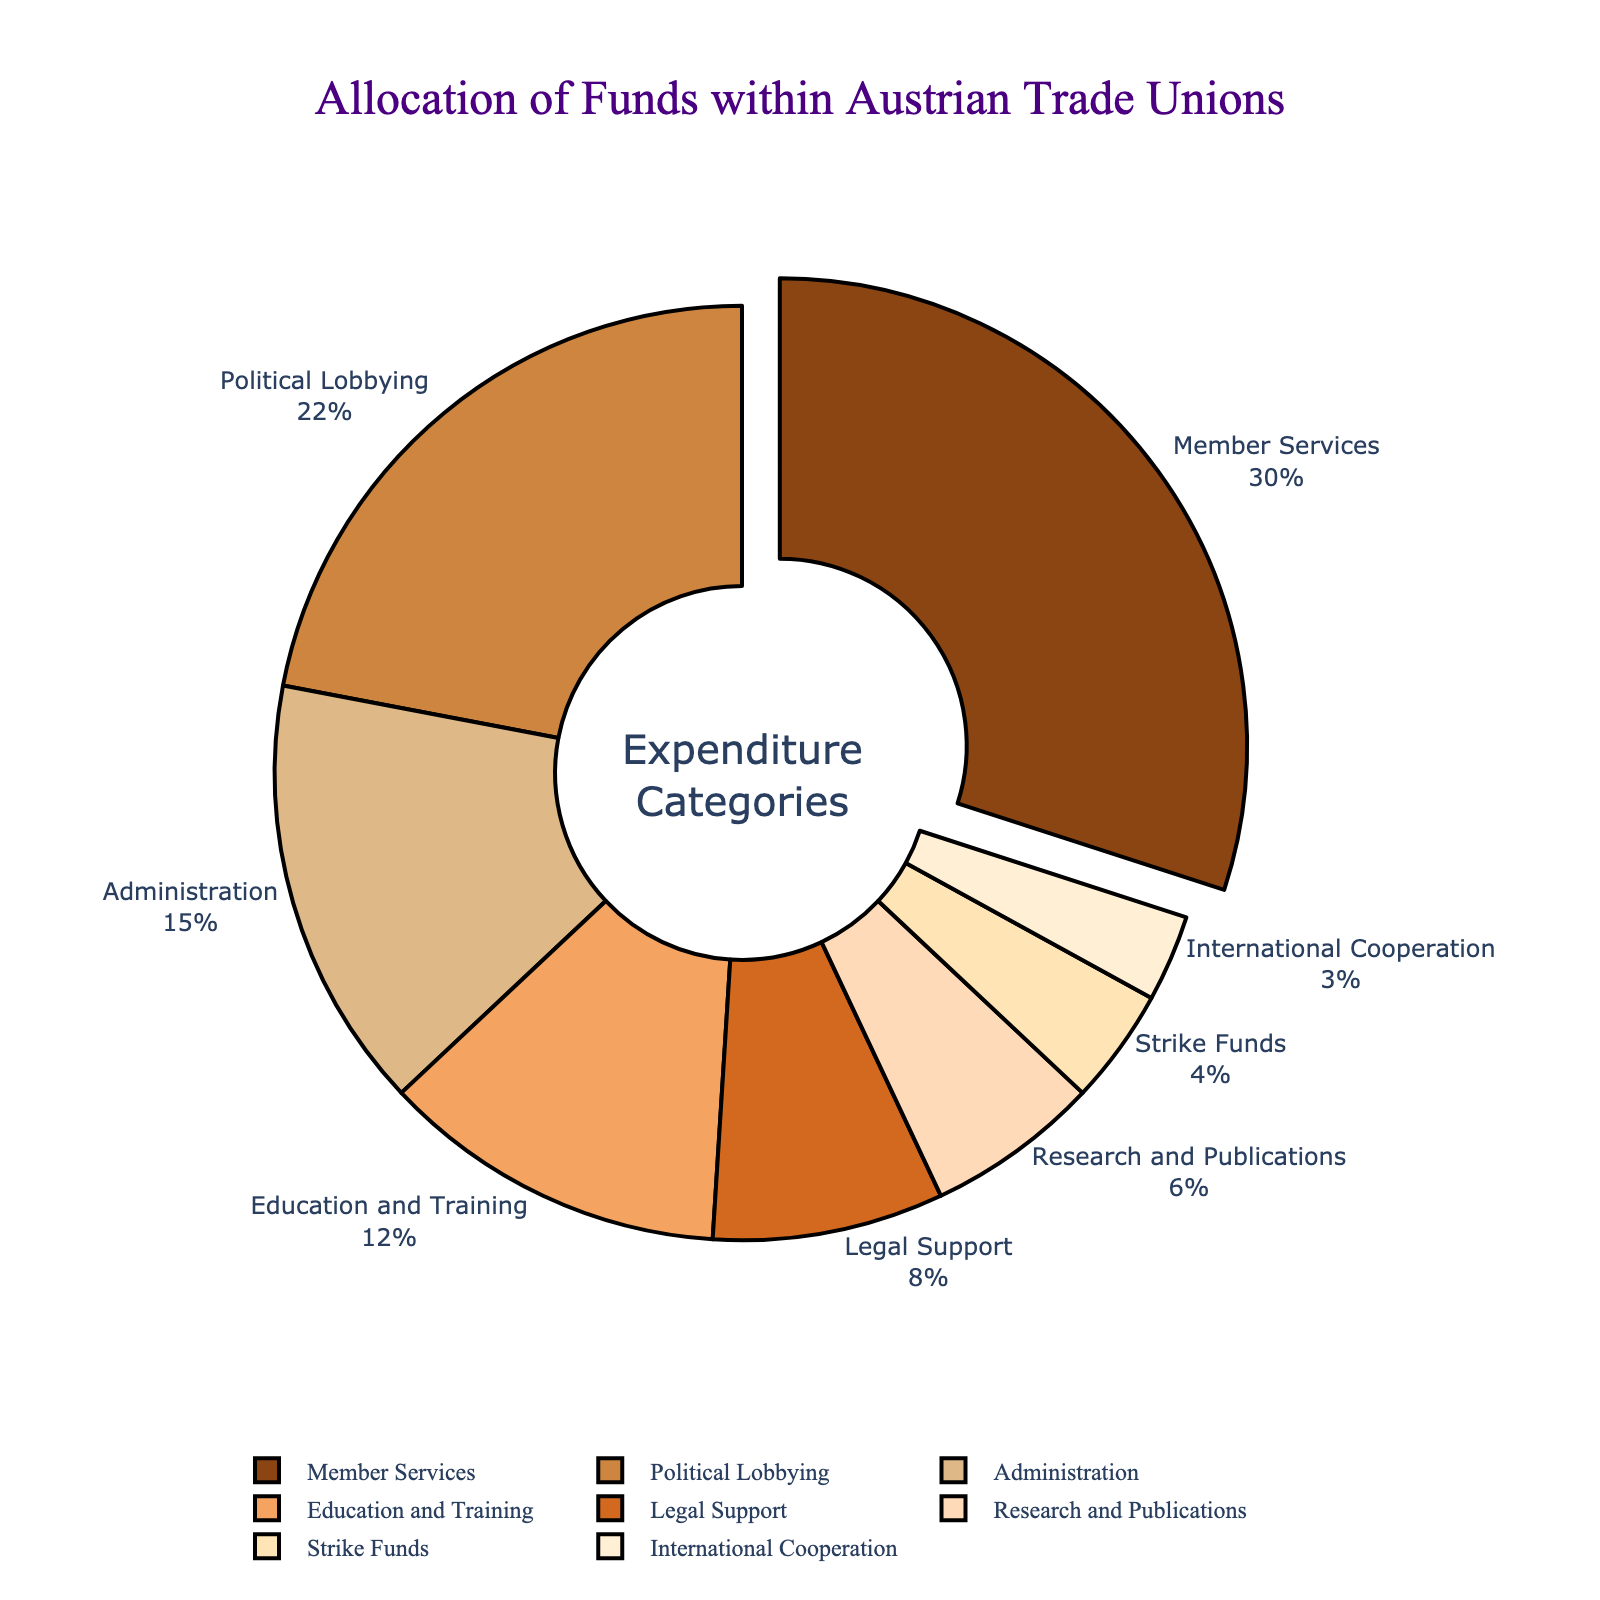What's the percentage allocated to Member Services? The pie chart provides a breakdown of different expenditure categories with their respective percentages. Member Services is allocated 30% of the total funds.
Answer: 30% How much more is allocated to Political Lobbying compared to Strike Funds? The pie chart shows Political Lobbying has 22% and Strike Funds have 4%. The difference is calculated as 22% - 4% = 18%.
Answer: 18% Which category has the smallest allocation, and what is its percentage? The chart shows multiple categories, with International Cooperation having the smallest slice. Its percentage is 3%.
Answer: International Cooperation, 3% What is the combined percentage for Education and Training and Legal Support? The pie chart shows Education and Training at 12% and Legal Support at 8%. Their combined percentage is 12% + 8% = 20%.
Answer: 20% Which category stands out visually, and why? The largest slice and the one that is slightly pulled out from the pie chart represents Member Services, which stands out visually due to its position and size.
Answer: Member Services Rank the top three categories by percentage allocation. By observing the pie chart segments, the top three categories in descending order are Member Services (30%), Political Lobbying (22%), and Administration (15%).
Answer: Member Services, Political Lobbying, Administration How much less is allocated to Research and Publications compared to Member Services? Research and Publications have 6%, while Member Services have 30%. The difference is 30% - 6% = 24%.
Answer: 24% What percentage of the total expenditure is allocated to categories other than Member Services? Member Services has 30%. Subtracting this from 100% gives the allocation for other categories: 100% - 30% = 70%.
Answer: 70% If Strike Funds and International Cooperation were combined into one category, what would be their total percentage? Strike Funds have 4% and International Cooperation has 3%. Combined, they would have 4% + 3% = 7%.
Answer: 7% How do Administration and Education and Training allocations compare visually? The pie chart shows Administration with 15% and Education and Training with 12%. The Administration slice is slightly larger than the Education and Training slice.
Answer: Administration is larger than Education and Training 